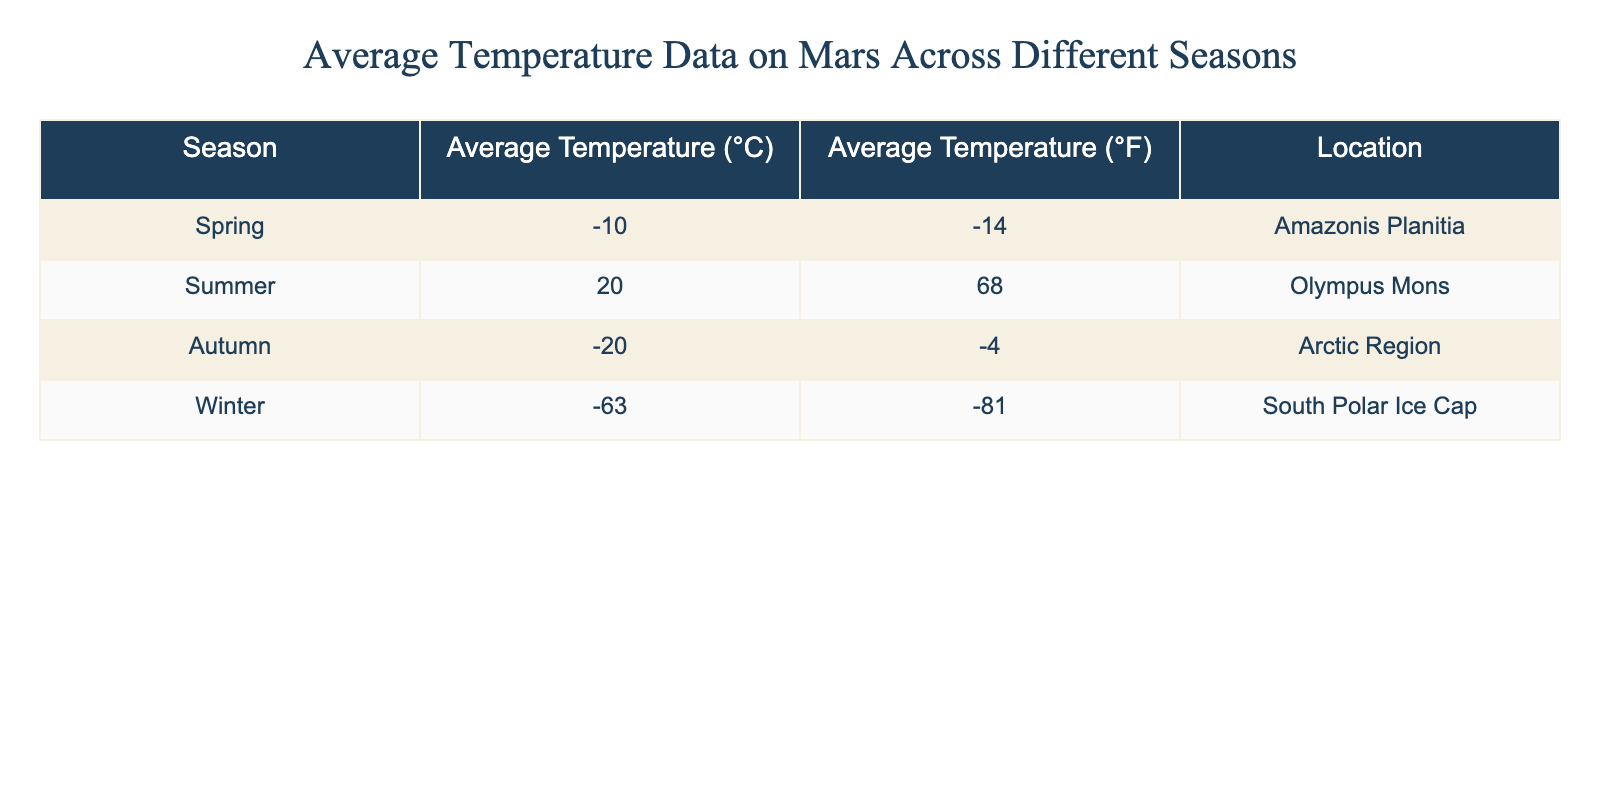What is the average temperature in the summer on Mars? The table lists the average temperature for summer as 20 °C.
Answer: 20 °C Which location has the lowest average temperature? The lowest average temperature listed in the table is -63 °C, found at the South Polar Ice Cap.
Answer: South Polar Ice Cap What is the difference in average temperature between autumn and spring? The average temperature in autumn is -20 °C and in spring, it is -10 °C. The difference is -10 - (-20) = 10 °C.
Answer: 10 °C Is the average temperature higher in summer than in winter? Summer's average is 20 °C, while winter's is -63 °C. Therefore, summer is indeed higher.
Answer: Yes What is the average of the average temperatures across all seasons? To find the average temperature across all four seasons (-10, 20, -20, -63), we first sum them: -10 + 20 + -20 + -63 = -73. Then, we divide by 4 (the number of seasons): -73/4 = -18.25 °C.
Answer: -18.25 °C In which season is the average temperature most extreme based on the table? The winter average temperature at -63 °C is more extreme than any other season listed, which are all above that temperature.
Answer: Winter Does autumn have a higher average temperature than spring? Autumn's average is -20 °C, while spring's is -10 °C. Therefore, autumn does not have a higher temperature than spring.
Answer: No What is the total sum of average temperatures in all locations? Adding all average temperatures together: -10 + 20 + -20 + -63 = -73 °C.
Answer: -73 °C Which season has a temperature close to freezing (0 °C)? Among the seasons listed, spring has the temperature closest to freezing at -10 °C, which is the least negative average temperature.
Answer: Spring 